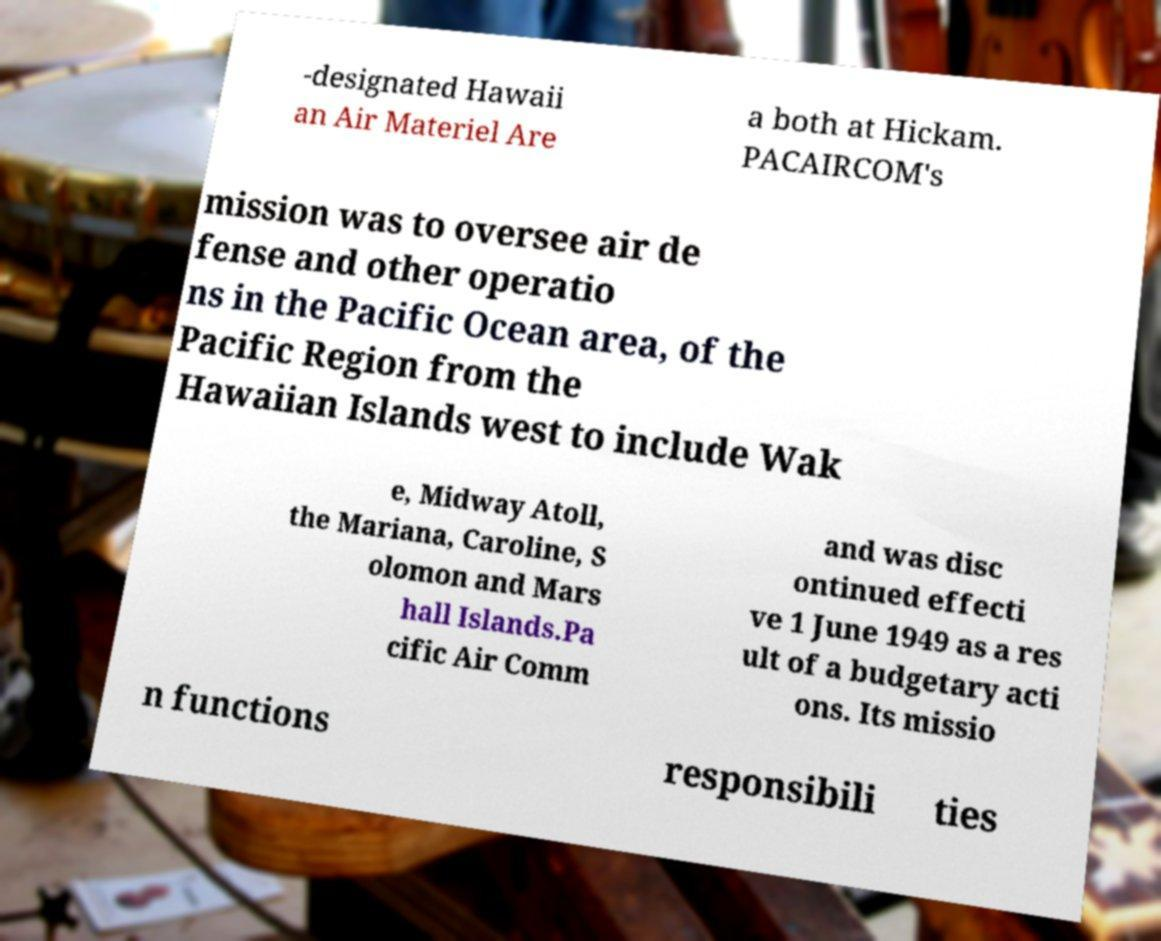Can you read and provide the text displayed in the image?This photo seems to have some interesting text. Can you extract and type it out for me? -designated Hawaii an Air Materiel Are a both at Hickam. PACAIRCOM's mission was to oversee air de fense and other operatio ns in the Pacific Ocean area, of the Pacific Region from the Hawaiian Islands west to include Wak e, Midway Atoll, the Mariana, Caroline, S olomon and Mars hall Islands.Pa cific Air Comm and was disc ontinued effecti ve 1 June 1949 as a res ult of a budgetary acti ons. Its missio n functions responsibili ties 